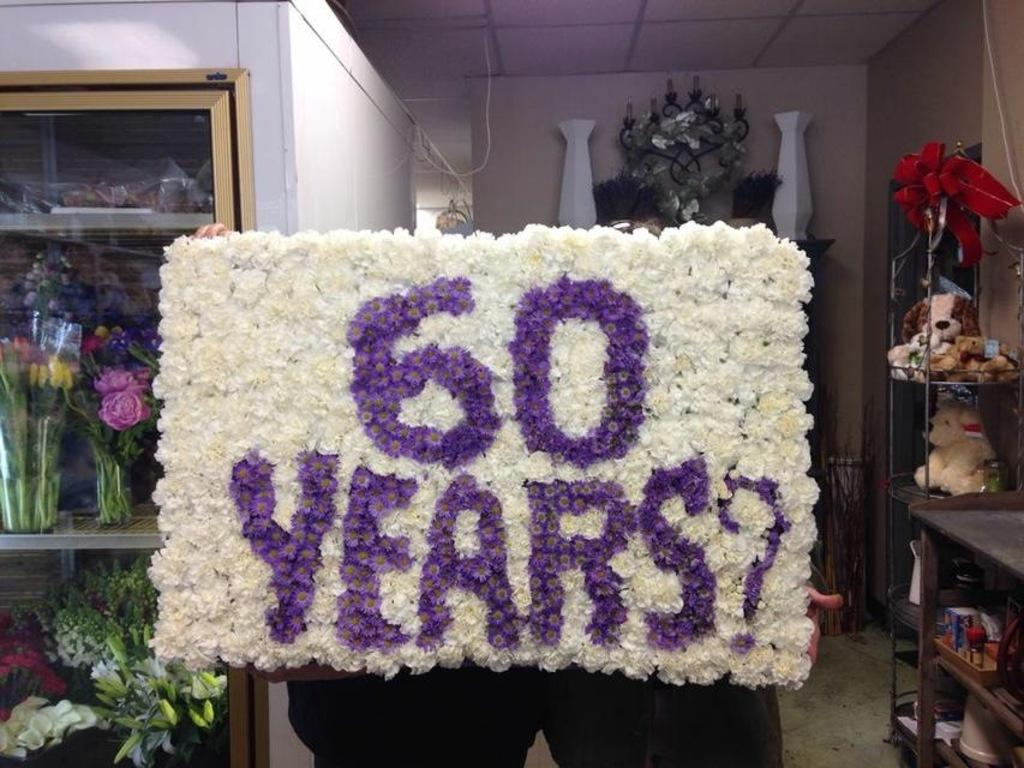<image>
Relay a brief, clear account of the picture shown. Person holding a sign made of white flowers and 60 years in purple. 